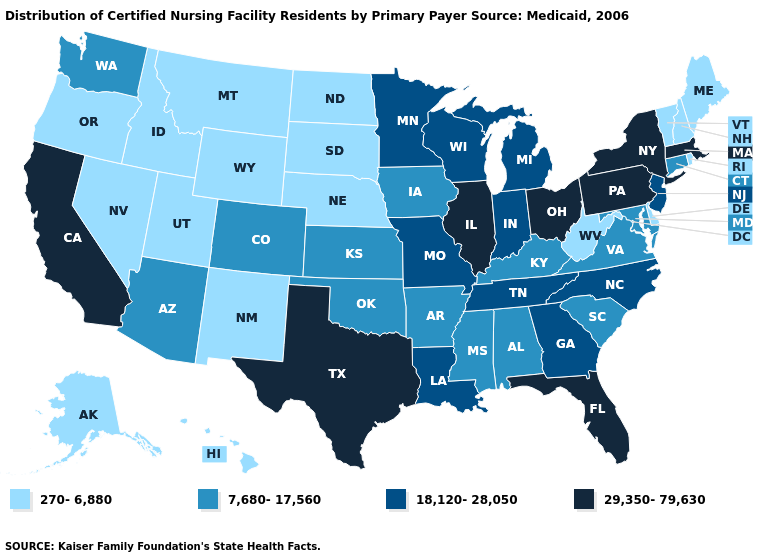Name the states that have a value in the range 270-6,880?
Be succinct. Alaska, Delaware, Hawaii, Idaho, Maine, Montana, Nebraska, Nevada, New Hampshire, New Mexico, North Dakota, Oregon, Rhode Island, South Dakota, Utah, Vermont, West Virginia, Wyoming. Name the states that have a value in the range 29,350-79,630?
Quick response, please. California, Florida, Illinois, Massachusetts, New York, Ohio, Pennsylvania, Texas. Name the states that have a value in the range 7,680-17,560?
Short answer required. Alabama, Arizona, Arkansas, Colorado, Connecticut, Iowa, Kansas, Kentucky, Maryland, Mississippi, Oklahoma, South Carolina, Virginia, Washington. What is the value of Idaho?
Short answer required. 270-6,880. What is the highest value in the USA?
Keep it brief. 29,350-79,630. What is the value of Washington?
Give a very brief answer. 7,680-17,560. What is the value of Maryland?
Answer briefly. 7,680-17,560. Does the map have missing data?
Answer briefly. No. What is the value of Rhode Island?
Quick response, please. 270-6,880. Does Hawaii have the highest value in the USA?
Quick response, please. No. Does the map have missing data?
Be succinct. No. What is the value of Tennessee?
Give a very brief answer. 18,120-28,050. What is the highest value in the South ?
Be succinct. 29,350-79,630. What is the value of Tennessee?
Answer briefly. 18,120-28,050. 